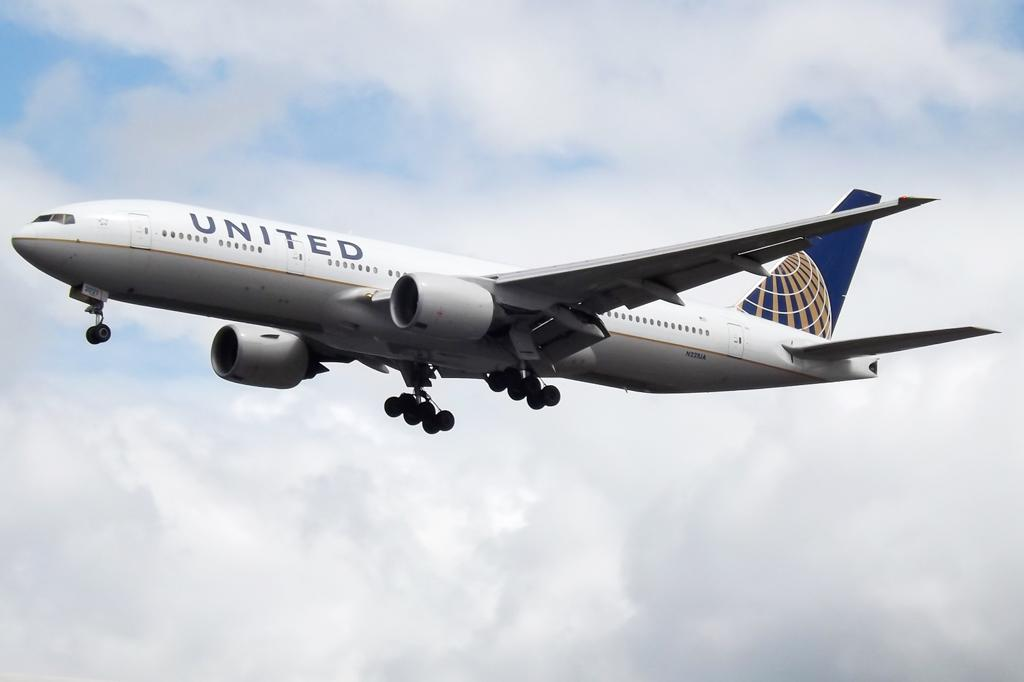<image>
Render a clear and concise summary of the photo. A plane owned by united flying in the sky 